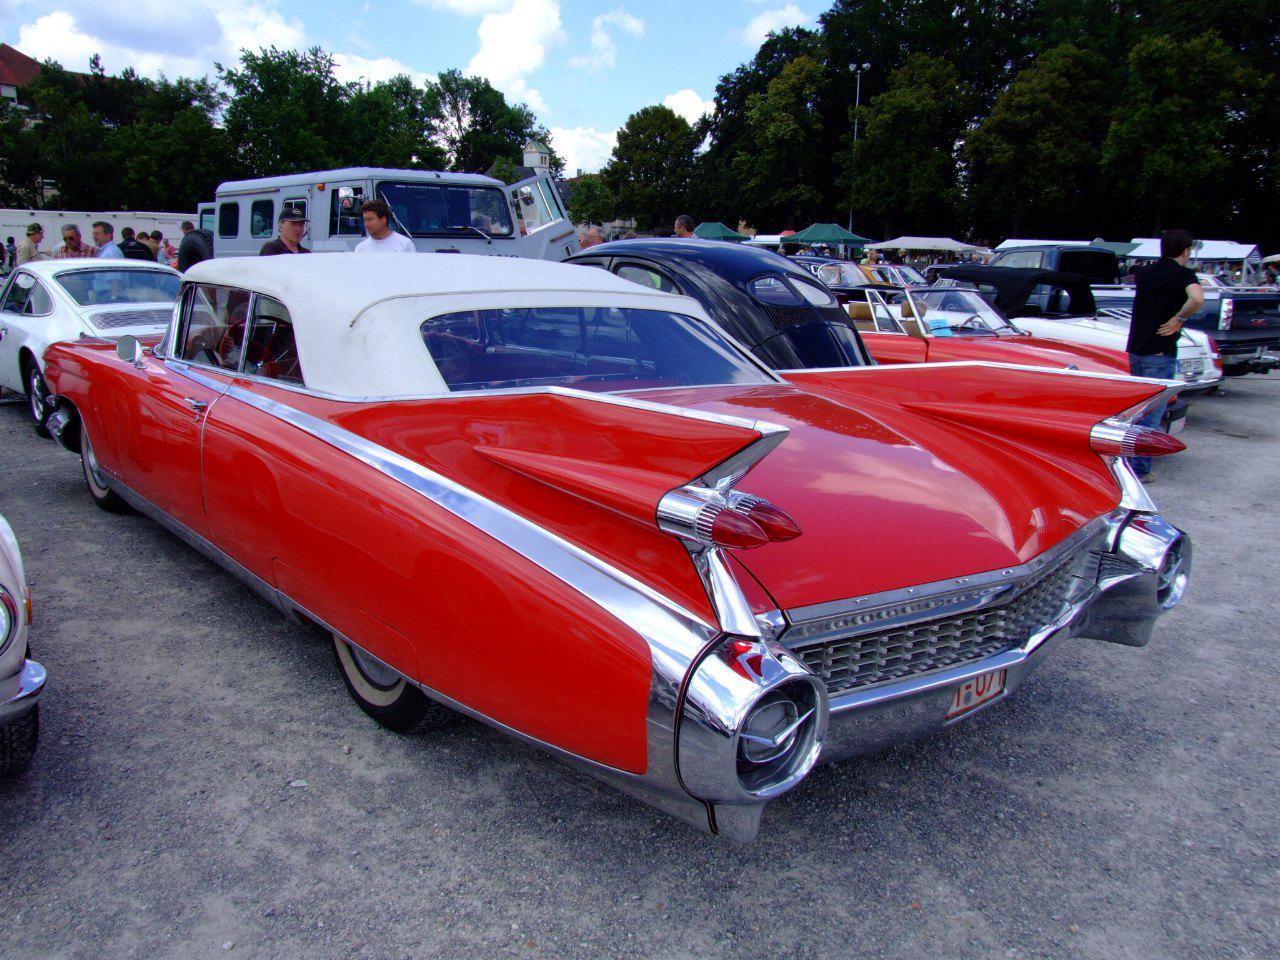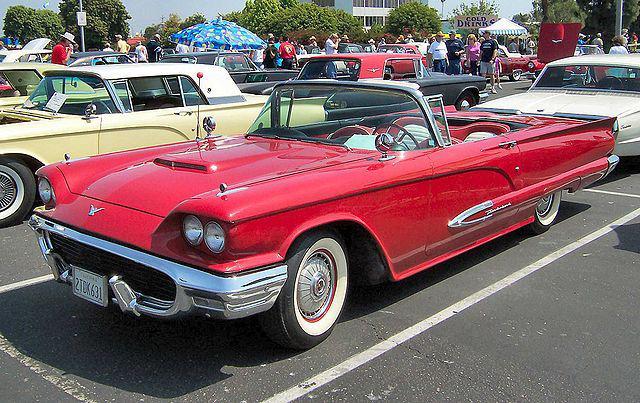The first image is the image on the left, the second image is the image on the right. For the images shown, is this caption "The car in the image on the left has its top up." true? Answer yes or no. Yes. The first image is the image on the left, the second image is the image on the right. Examine the images to the left and right. Is the description "One image shows a red soft-topped vintage car with missile-like red lights and jutting fins, and the other image shows a red topless vintage convertible." accurate? Answer yes or no. Yes. 